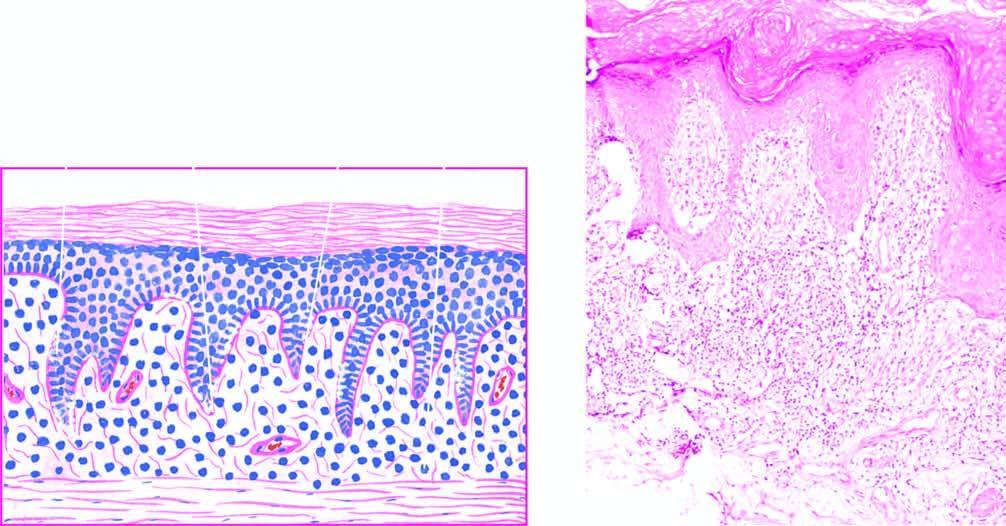does bone biopsy show a band-like mononuclear infiltrate with a sharply-demarcated lower border?
Answer the question using a single word or phrase. No 